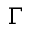Convert formula to latex. <formula><loc_0><loc_0><loc_500><loc_500>\Gamma</formula> 